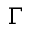Convert formula to latex. <formula><loc_0><loc_0><loc_500><loc_500>\Gamma</formula> 